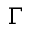Convert formula to latex. <formula><loc_0><loc_0><loc_500><loc_500>\Gamma</formula> 